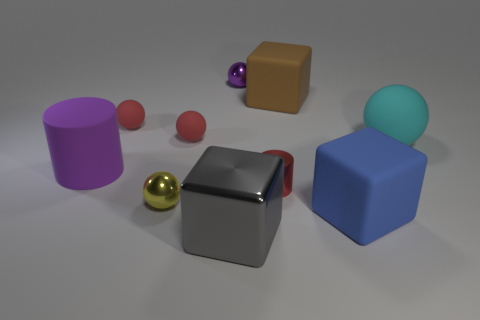How many things are small red balls or purple objects in front of the cyan ball?
Make the answer very short. 3. Does the tiny red cylinder have the same material as the small yellow sphere?
Offer a very short reply. Yes. How many other objects are the same material as the gray block?
Your response must be concise. 3. Are there more small red shiny cylinders than tiny purple matte blocks?
Keep it short and to the point. Yes. There is a shiny thing behind the big purple object; does it have the same shape as the small yellow metallic thing?
Your answer should be very brief. Yes. Is the number of rubber things less than the number of tiny shiny spheres?
Your answer should be compact. No. There is a gray object that is the same size as the purple rubber cylinder; what is it made of?
Your response must be concise. Metal. Is the color of the small cylinder the same as the small ball that is to the right of the gray shiny block?
Offer a very short reply. No. Is the number of big brown cubes on the right side of the big brown rubber block less than the number of big shiny cubes?
Your answer should be compact. Yes. What number of tiny red objects are there?
Ensure brevity in your answer.  3. 